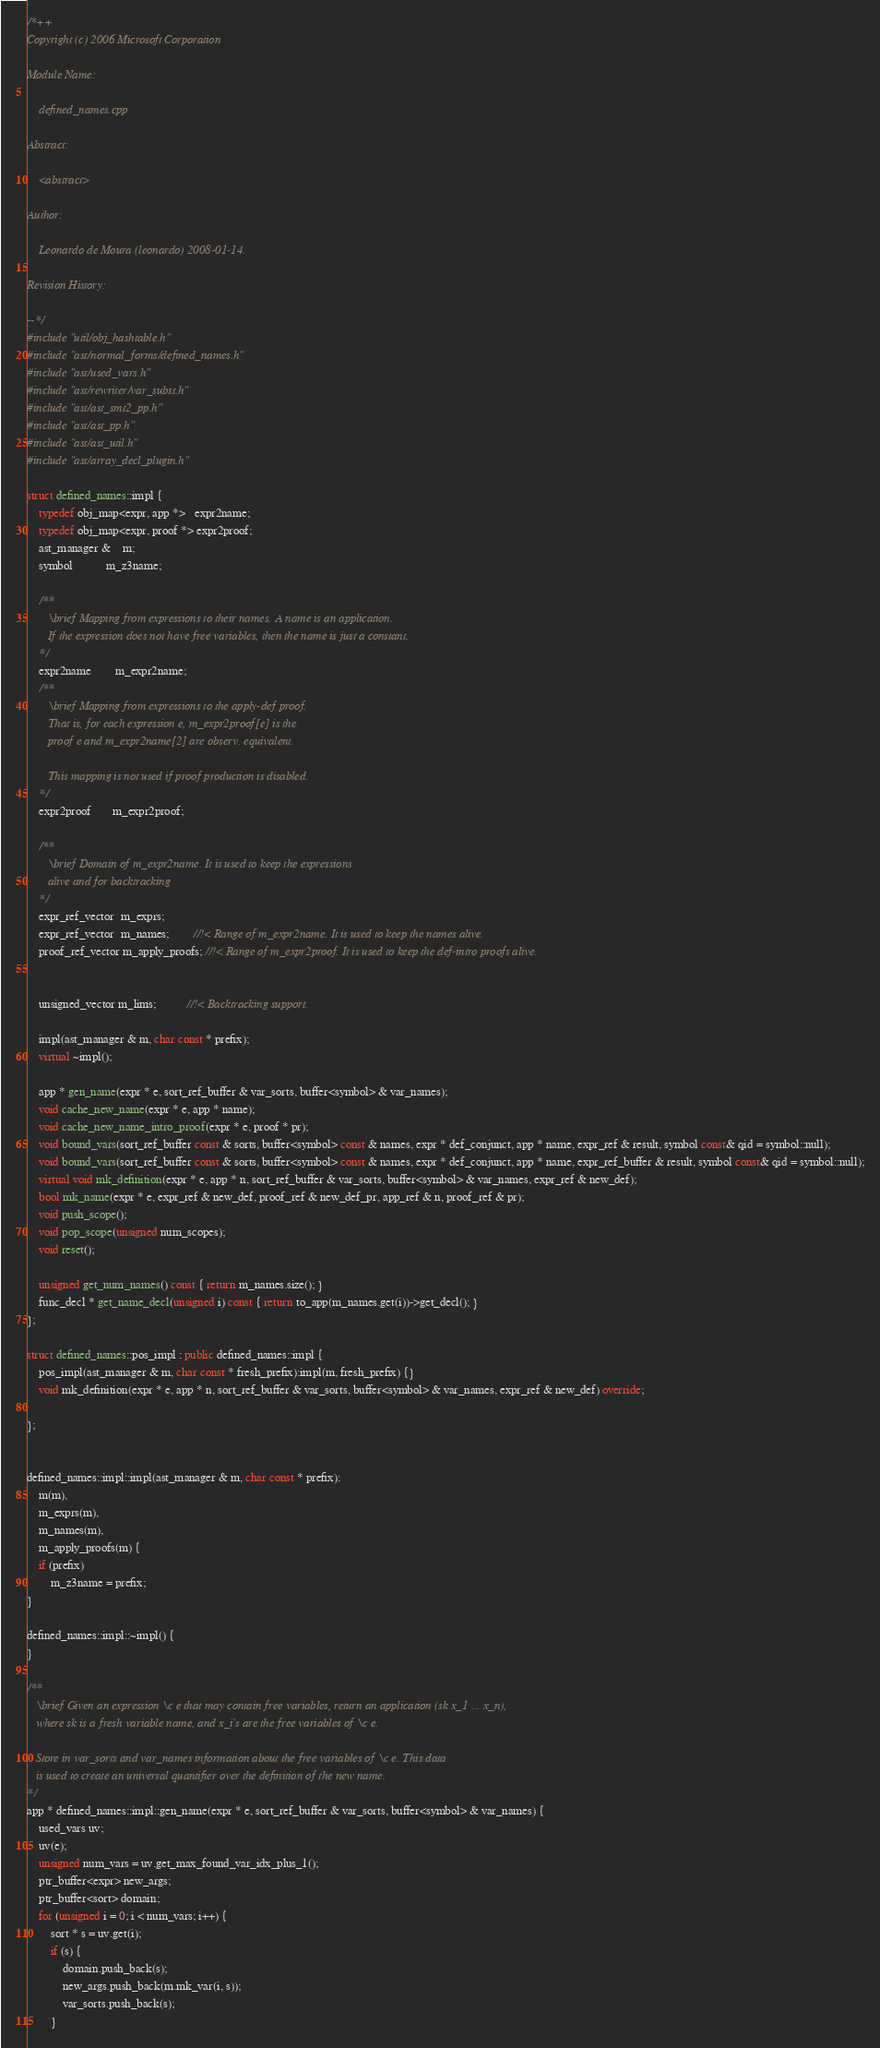Convert code to text. <code><loc_0><loc_0><loc_500><loc_500><_C++_>/*++
Copyright (c) 2006 Microsoft Corporation

Module Name:

    defined_names.cpp

Abstract:

    <abstract>

Author:

    Leonardo de Moura (leonardo) 2008-01-14.

Revision History:

--*/
#include "util/obj_hashtable.h"
#include "ast/normal_forms/defined_names.h"
#include "ast/used_vars.h"
#include "ast/rewriter/var_subst.h"
#include "ast/ast_smt2_pp.h"
#include "ast/ast_pp.h"
#include "ast/ast_util.h"
#include "ast/array_decl_plugin.h"

struct defined_names::impl {
    typedef obj_map<expr, app *>   expr2name;
    typedef obj_map<expr, proof *> expr2proof;
    ast_manager &    m;
    symbol           m_z3name;

    /**
       \brief Mapping from expressions to their names. A name is an application.
       If the expression does not have free variables, then the name is just a constant.
    */
    expr2name        m_expr2name;
    /**
       \brief Mapping from expressions to the apply-def proof.
       That is, for each expression e, m_expr2proof[e] is the
       proof e and m_expr2name[2] are observ. equivalent.

       This mapping is not used if proof production is disabled.
    */
    expr2proof       m_expr2proof;

    /**
       \brief Domain of m_expr2name. It is used to keep the expressions
       alive and for backtracking
    */
    expr_ref_vector  m_exprs;
    expr_ref_vector  m_names;        //!< Range of m_expr2name. It is used to keep the names alive.
    proof_ref_vector m_apply_proofs; //!< Range of m_expr2proof. It is used to keep the def-intro proofs alive.


    unsigned_vector m_lims;          //!< Backtracking support.

    impl(ast_manager & m, char const * prefix);
    virtual ~impl();

    app * gen_name(expr * e, sort_ref_buffer & var_sorts, buffer<symbol> & var_names);
    void cache_new_name(expr * e, app * name);
    void cache_new_name_intro_proof(expr * e, proof * pr);
    void bound_vars(sort_ref_buffer const & sorts, buffer<symbol> const & names, expr * def_conjunct, app * name, expr_ref & result, symbol const& qid = symbol::null);
    void bound_vars(sort_ref_buffer const & sorts, buffer<symbol> const & names, expr * def_conjunct, app * name, expr_ref_buffer & result, symbol const& qid = symbol::null);
    virtual void mk_definition(expr * e, app * n, sort_ref_buffer & var_sorts, buffer<symbol> & var_names, expr_ref & new_def);
    bool mk_name(expr * e, expr_ref & new_def, proof_ref & new_def_pr, app_ref & n, proof_ref & pr);
    void push_scope();
    void pop_scope(unsigned num_scopes);
    void reset();

    unsigned get_num_names() const { return m_names.size(); }
    func_decl * get_name_decl(unsigned i) const { return to_app(m_names.get(i))->get_decl(); }
};

struct defined_names::pos_impl : public defined_names::impl {
    pos_impl(ast_manager & m, char const * fresh_prefix):impl(m, fresh_prefix) {}
    void mk_definition(expr * e, app * n, sort_ref_buffer & var_sorts, buffer<symbol> & var_names, expr_ref & new_def) override;

};


defined_names::impl::impl(ast_manager & m, char const * prefix):
    m(m),
    m_exprs(m),
    m_names(m),
    m_apply_proofs(m) {
    if (prefix)
        m_z3name = prefix;
}

defined_names::impl::~impl() {
}

/**
   \brief Given an expression \c e that may contain free variables, return an application (sk x_1 ... x_n),
   where sk is a fresh variable name, and x_i's are the free variables of \c e.

   Store in var_sorts and var_names information about the free variables of \c e. This data
   is used to create an universal quantifier over the definition of the new name.
*/
app * defined_names::impl::gen_name(expr * e, sort_ref_buffer & var_sorts, buffer<symbol> & var_names) {
    used_vars uv;
    uv(e);
    unsigned num_vars = uv.get_max_found_var_idx_plus_1();
    ptr_buffer<expr> new_args;
    ptr_buffer<sort> domain;
    for (unsigned i = 0; i < num_vars; i++) {
        sort * s = uv.get(i);
        if (s) {
            domain.push_back(s);
            new_args.push_back(m.mk_var(i, s));
            var_sorts.push_back(s);
        }</code> 